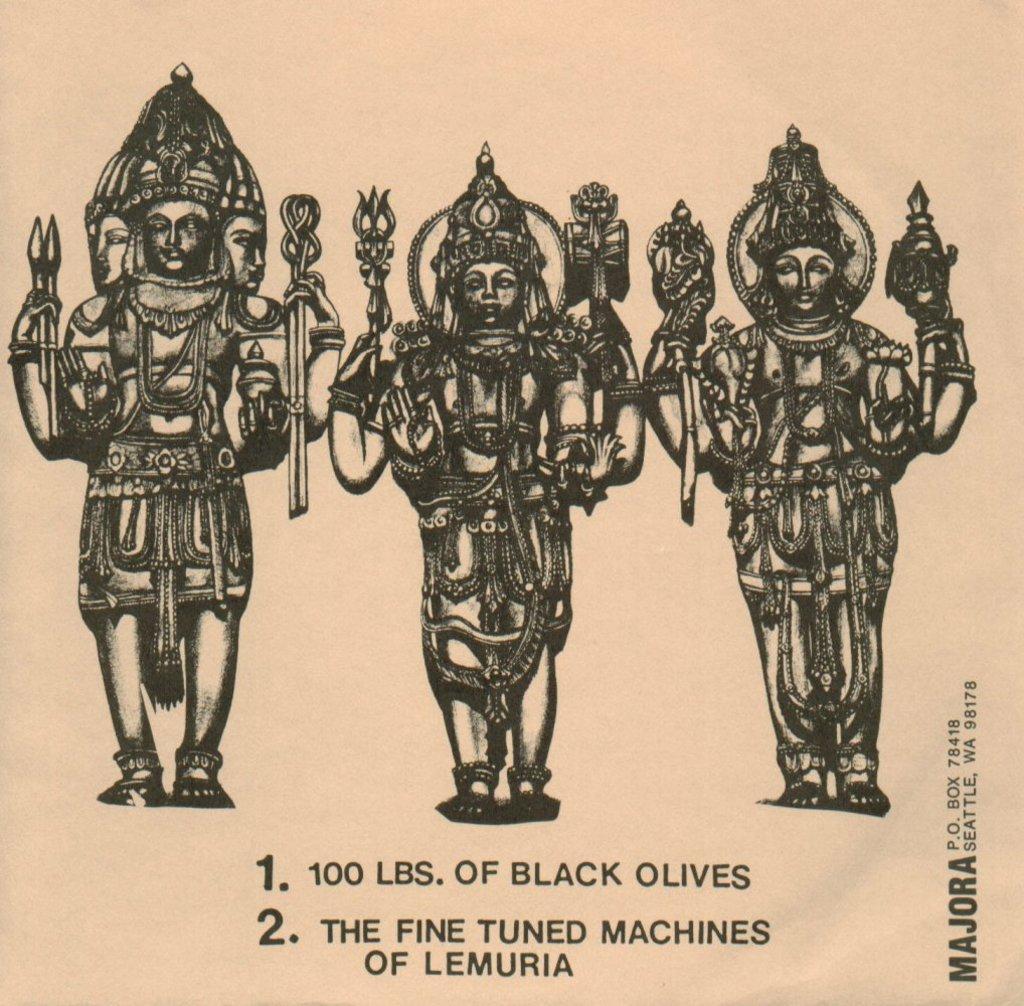How would you summarize this image in a sentence or two? In this image we can see sketches of an idol printed on paper. At the bottom there is text. 